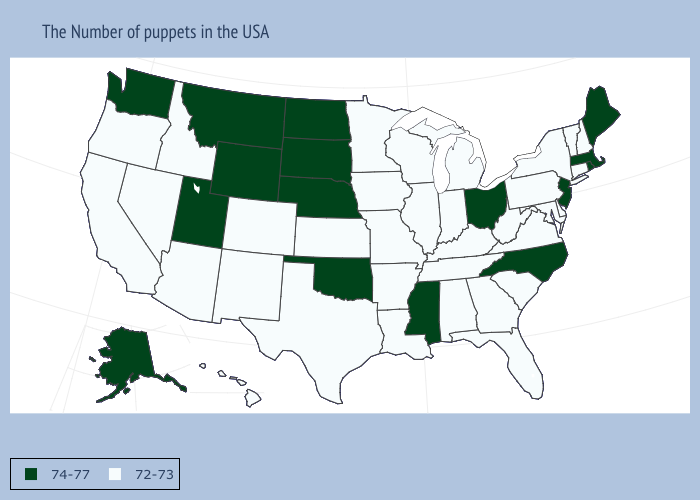Which states have the lowest value in the USA?
Concise answer only. New Hampshire, Vermont, Connecticut, New York, Delaware, Maryland, Pennsylvania, Virginia, South Carolina, West Virginia, Florida, Georgia, Michigan, Kentucky, Indiana, Alabama, Tennessee, Wisconsin, Illinois, Louisiana, Missouri, Arkansas, Minnesota, Iowa, Kansas, Texas, Colorado, New Mexico, Arizona, Idaho, Nevada, California, Oregon, Hawaii. Is the legend a continuous bar?
Answer briefly. No. Does Minnesota have a higher value than Nebraska?
Concise answer only. No. Name the states that have a value in the range 74-77?
Quick response, please. Maine, Massachusetts, Rhode Island, New Jersey, North Carolina, Ohio, Mississippi, Nebraska, Oklahoma, South Dakota, North Dakota, Wyoming, Utah, Montana, Washington, Alaska. Does Wyoming have the same value as New Jersey?
Short answer required. Yes. Which states hav the highest value in the MidWest?
Give a very brief answer. Ohio, Nebraska, South Dakota, North Dakota. Among the states that border Texas , which have the highest value?
Give a very brief answer. Oklahoma. What is the value of West Virginia?
Keep it brief. 72-73. What is the value of Illinois?
Give a very brief answer. 72-73. Name the states that have a value in the range 74-77?
Give a very brief answer. Maine, Massachusetts, Rhode Island, New Jersey, North Carolina, Ohio, Mississippi, Nebraska, Oklahoma, South Dakota, North Dakota, Wyoming, Utah, Montana, Washington, Alaska. Name the states that have a value in the range 74-77?
Write a very short answer. Maine, Massachusetts, Rhode Island, New Jersey, North Carolina, Ohio, Mississippi, Nebraska, Oklahoma, South Dakota, North Dakota, Wyoming, Utah, Montana, Washington, Alaska. What is the highest value in the West ?
Answer briefly. 74-77. Does the map have missing data?
Be succinct. No. Does California have a lower value than Wisconsin?
Quick response, please. No. 